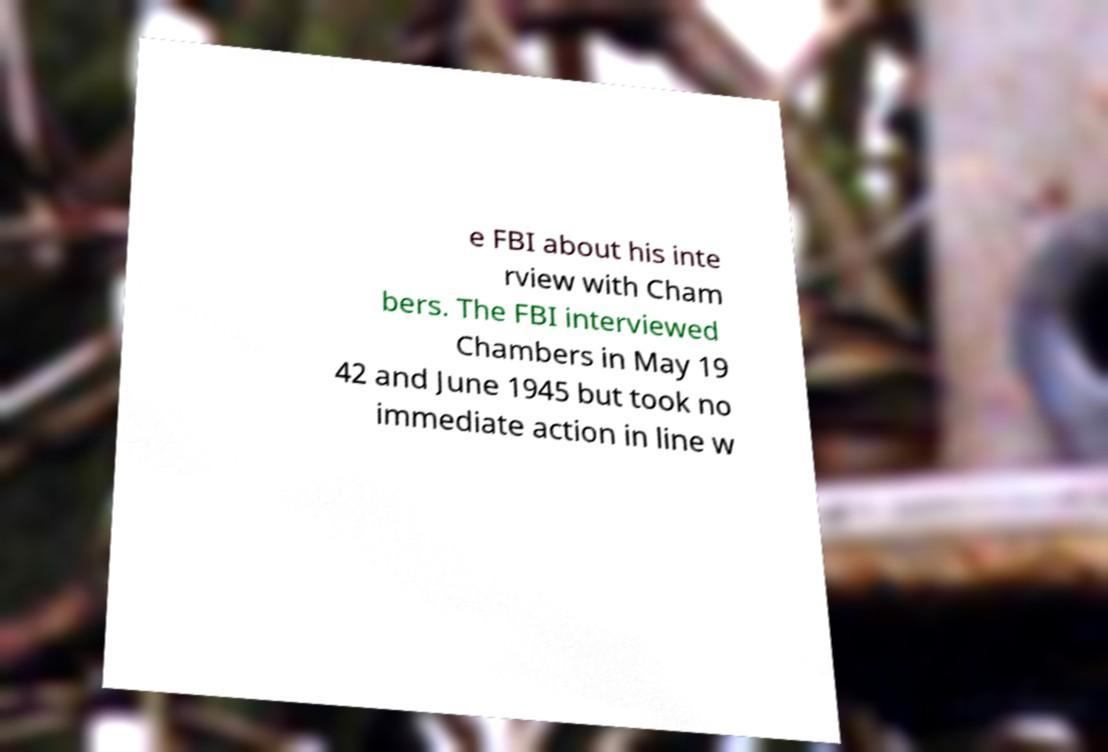Can you read and provide the text displayed in the image?This photo seems to have some interesting text. Can you extract and type it out for me? e FBI about his inte rview with Cham bers. The FBI interviewed Chambers in May 19 42 and June 1945 but took no immediate action in line w 